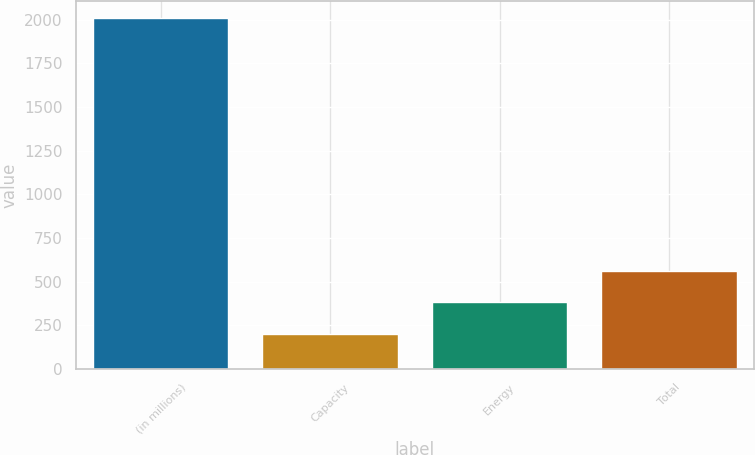<chart> <loc_0><loc_0><loc_500><loc_500><bar_chart><fcel>(in millions)<fcel>Capacity<fcel>Energy<fcel>Total<nl><fcel>2007<fcel>202<fcel>382.5<fcel>563<nl></chart> 